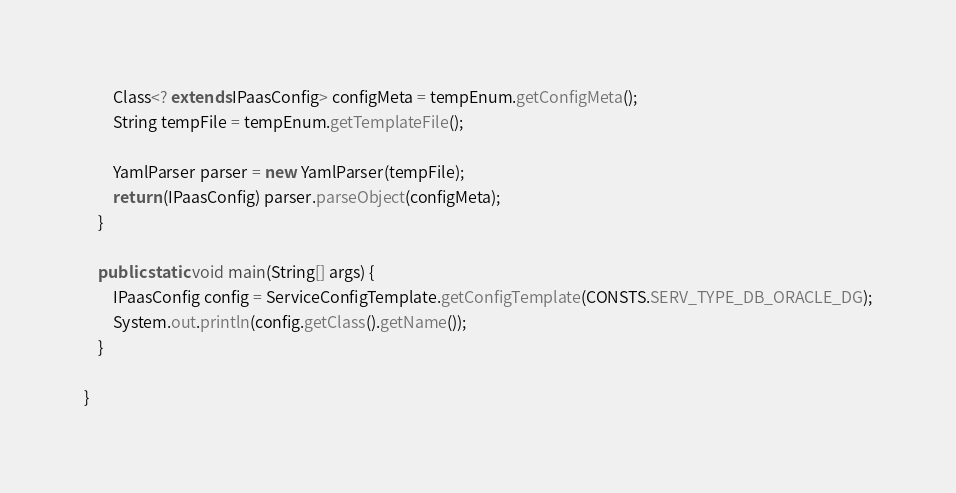Convert code to text. <code><loc_0><loc_0><loc_500><loc_500><_Java_>        Class<? extends IPaasConfig> configMeta = tempEnum.getConfigMeta();
        String tempFile = tempEnum.getTemplateFile();
        
        YamlParser parser = new YamlParser(tempFile);
        return (IPaasConfig) parser.parseObject(configMeta);
    }
    
    public static void main(String[] args) {
        IPaasConfig config = ServiceConfigTemplate.getConfigTemplate(CONSTS.SERV_TYPE_DB_ORACLE_DG);
        System.out.println(config.getClass().getName());
    }

}
</code> 